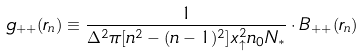<formula> <loc_0><loc_0><loc_500><loc_500>g _ { + + } ( r _ { n } ) \equiv \frac { 1 } { \Delta ^ { 2 } \pi [ n ^ { 2 } - ( n - 1 ) ^ { 2 } ] x _ { \uparrow } ^ { 2 } n _ { 0 } N _ { * } } \cdot B _ { + + } ( r _ { n } )</formula> 